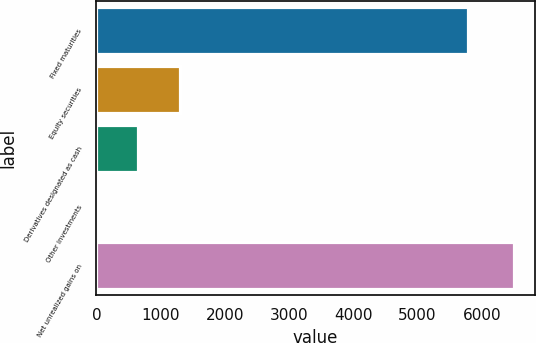<chart> <loc_0><loc_0><loc_500><loc_500><bar_chart><fcel>Fixed maturities<fcel>Equity securities<fcel>Derivatives designated as cash<fcel>Other investments<fcel>Net unrealized gains on<nl><fcel>5788<fcel>1300.6<fcel>650.8<fcel>1<fcel>6499<nl></chart> 